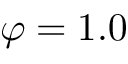<formula> <loc_0><loc_0><loc_500><loc_500>\varphi = 1 . 0</formula> 